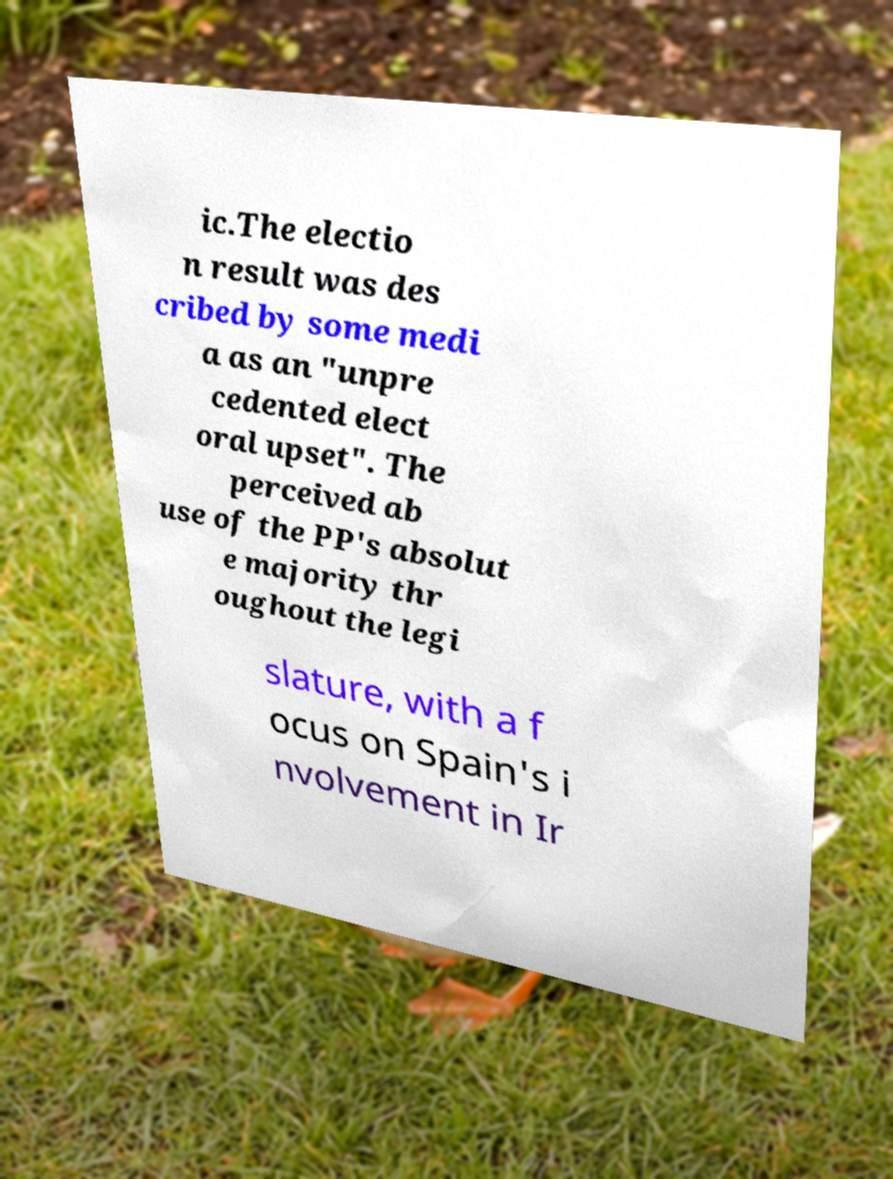For documentation purposes, I need the text within this image transcribed. Could you provide that? ic.The electio n result was des cribed by some medi a as an "unpre cedented elect oral upset". The perceived ab use of the PP's absolut e majority thr oughout the legi slature, with a f ocus on Spain's i nvolvement in Ir 